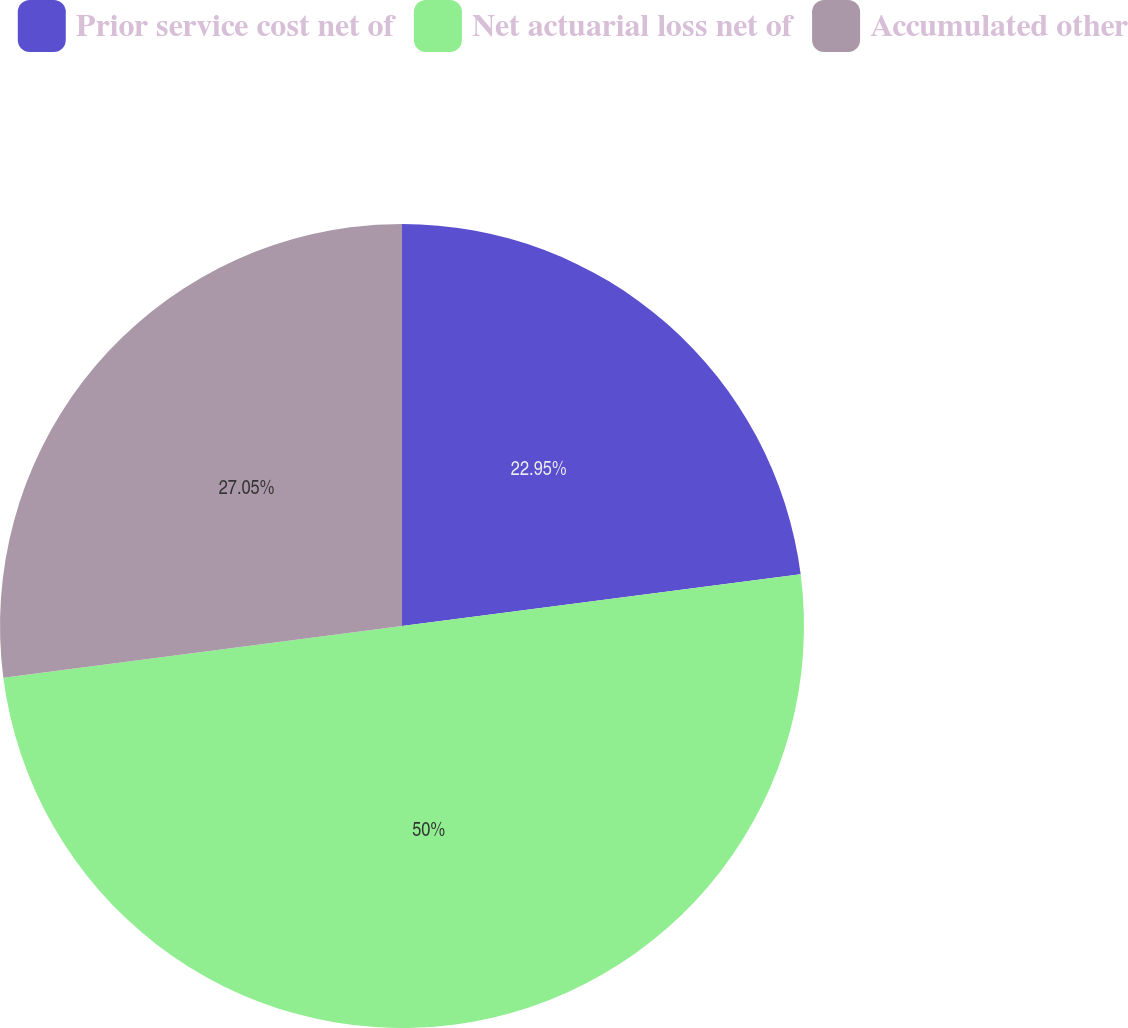<chart> <loc_0><loc_0><loc_500><loc_500><pie_chart><fcel>Prior service cost net of<fcel>Net actuarial loss net of<fcel>Accumulated other<nl><fcel>22.95%<fcel>50.0%<fcel>27.05%<nl></chart> 